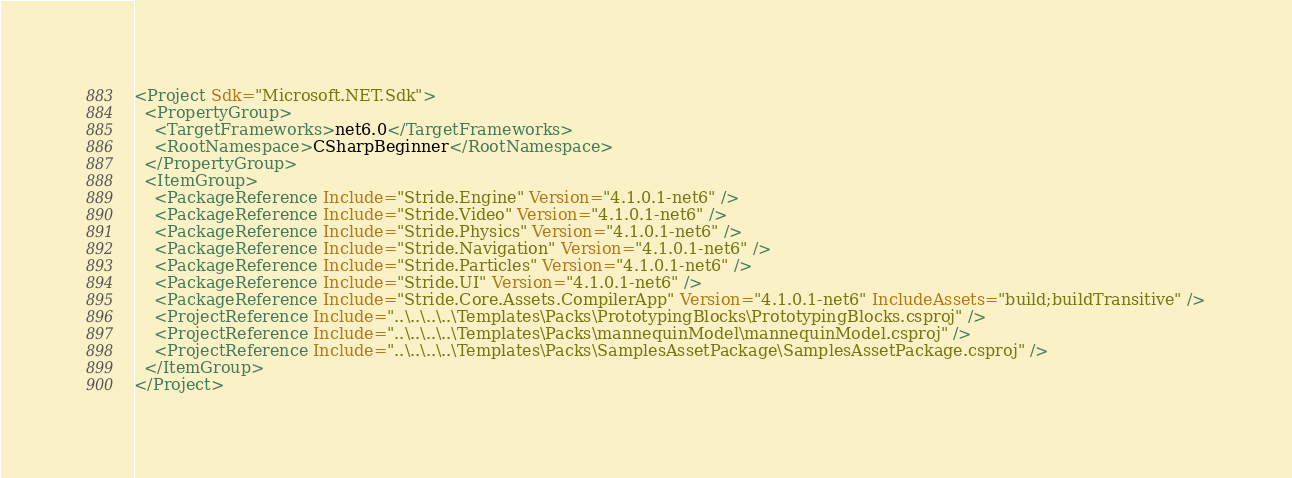Convert code to text. <code><loc_0><loc_0><loc_500><loc_500><_XML_><Project Sdk="Microsoft.NET.Sdk">
  <PropertyGroup>
    <TargetFrameworks>net6.0</TargetFrameworks>
    <RootNamespace>CSharpBeginner</RootNamespace>
  </PropertyGroup>
  <ItemGroup>
    <PackageReference Include="Stride.Engine" Version="4.1.0.1-net6" />
    <PackageReference Include="Stride.Video" Version="4.1.0.1-net6" />
    <PackageReference Include="Stride.Physics" Version="4.1.0.1-net6" />
    <PackageReference Include="Stride.Navigation" Version="4.1.0.1-net6" />
    <PackageReference Include="Stride.Particles" Version="4.1.0.1-net6" />
    <PackageReference Include="Stride.UI" Version="4.1.0.1-net6" />
    <PackageReference Include="Stride.Core.Assets.CompilerApp" Version="4.1.0.1-net6" IncludeAssets="build;buildTransitive" />
    <ProjectReference Include="..\..\..\..\Templates\Packs\PrototypingBlocks\PrototypingBlocks.csproj" />
    <ProjectReference Include="..\..\..\..\Templates\Packs\mannequinModel\mannequinModel.csproj" />
    <ProjectReference Include="..\..\..\..\Templates\Packs\SamplesAssetPackage\SamplesAssetPackage.csproj" />
  </ItemGroup>
</Project></code> 